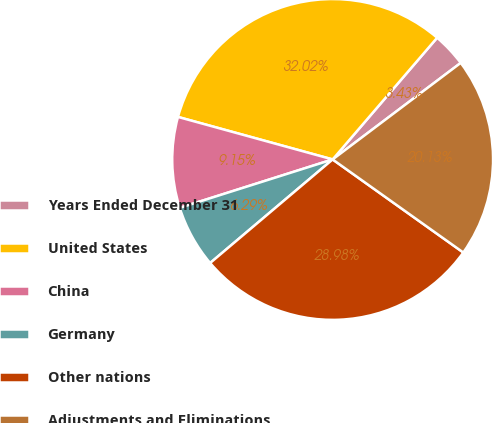<chart> <loc_0><loc_0><loc_500><loc_500><pie_chart><fcel>Years Ended December 31<fcel>United States<fcel>China<fcel>Germany<fcel>Other nations<fcel>Adjustments and Eliminations<nl><fcel>3.43%<fcel>32.02%<fcel>9.15%<fcel>6.29%<fcel>28.98%<fcel>20.13%<nl></chart> 